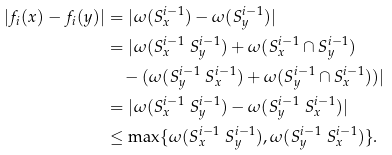Convert formula to latex. <formula><loc_0><loc_0><loc_500><loc_500>| f _ { i } ( x ) - f _ { i } ( y ) | & = | \omega ( S _ { x } ^ { i - 1 } ) - \omega ( S _ { y } ^ { i - 1 } ) | \\ & = | \omega ( S _ { x } ^ { i - 1 } \ S _ { y } ^ { i - 1 } ) + \omega ( S _ { x } ^ { i - 1 } \cap S _ { y } ^ { i - 1 } ) \\ & \quad - ( \omega ( S _ { y } ^ { i - 1 } \ S _ { x } ^ { i - 1 } ) + \omega ( S _ { y } ^ { i - 1 } \cap S _ { x } ^ { i - 1 } ) ) | \\ & = | \omega ( S _ { x } ^ { i - 1 } \ S _ { y } ^ { i - 1 } ) - \omega ( S _ { y } ^ { i - 1 } \ S _ { x } ^ { i - 1 } ) | \\ & \leq \max \{ \omega ( S _ { x } ^ { i - 1 } \ S _ { y } ^ { i - 1 } ) , \omega ( S _ { y } ^ { i - 1 } \ S _ { x } ^ { i - 1 } ) \} .</formula> 